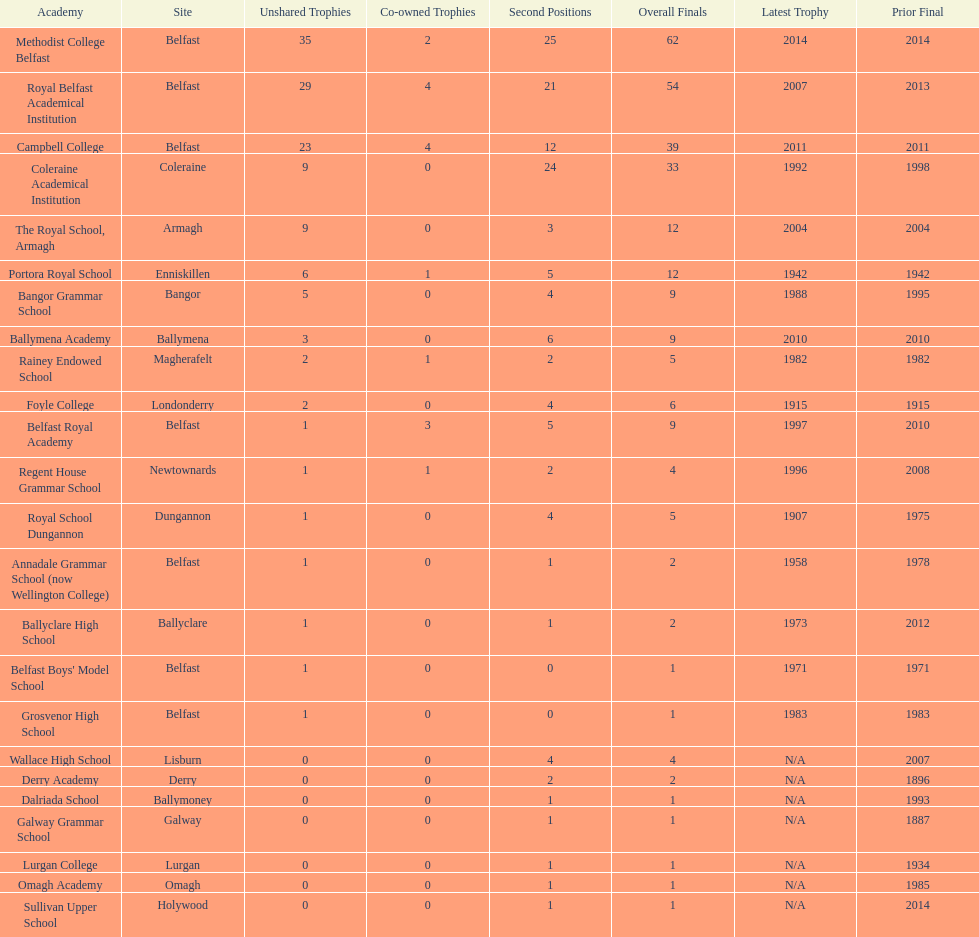Could you parse the entire table? {'header': ['Academy', 'Site', 'Unshared Trophies', 'Co-owned Trophies', 'Second Positions', 'Overall Finals', 'Latest Trophy', 'Prior Final'], 'rows': [['Methodist College Belfast', 'Belfast', '35', '2', '25', '62', '2014', '2014'], ['Royal Belfast Academical Institution', 'Belfast', '29', '4', '21', '54', '2007', '2013'], ['Campbell College', 'Belfast', '23', '4', '12', '39', '2011', '2011'], ['Coleraine Academical Institution', 'Coleraine', '9', '0', '24', '33', '1992', '1998'], ['The Royal School, Armagh', 'Armagh', '9', '0', '3', '12', '2004', '2004'], ['Portora Royal School', 'Enniskillen', '6', '1', '5', '12', '1942', '1942'], ['Bangor Grammar School', 'Bangor', '5', '0', '4', '9', '1988', '1995'], ['Ballymena Academy', 'Ballymena', '3', '0', '6', '9', '2010', '2010'], ['Rainey Endowed School', 'Magherafelt', '2', '1', '2', '5', '1982', '1982'], ['Foyle College', 'Londonderry', '2', '0', '4', '6', '1915', '1915'], ['Belfast Royal Academy', 'Belfast', '1', '3', '5', '9', '1997', '2010'], ['Regent House Grammar School', 'Newtownards', '1', '1', '2', '4', '1996', '2008'], ['Royal School Dungannon', 'Dungannon', '1', '0', '4', '5', '1907', '1975'], ['Annadale Grammar School (now Wellington College)', 'Belfast', '1', '0', '1', '2', '1958', '1978'], ['Ballyclare High School', 'Ballyclare', '1', '0', '1', '2', '1973', '2012'], ["Belfast Boys' Model School", 'Belfast', '1', '0', '0', '1', '1971', '1971'], ['Grosvenor High School', 'Belfast', '1', '0', '0', '1', '1983', '1983'], ['Wallace High School', 'Lisburn', '0', '0', '4', '4', 'N/A', '2007'], ['Derry Academy', 'Derry', '0', '0', '2', '2', 'N/A', '1896'], ['Dalriada School', 'Ballymoney', '0', '0', '1', '1', 'N/A', '1993'], ['Galway Grammar School', 'Galway', '0', '0', '1', '1', 'N/A', '1887'], ['Lurgan College', 'Lurgan', '0', '0', '1', '1', 'N/A', '1934'], ['Omagh Academy', 'Omagh', '0', '0', '1', '1', 'N/A', '1985'], ['Sullivan Upper School', 'Holywood', '0', '0', '1', '1', 'N/A', '2014']]} What number of total finals does foyle college have? 6. 